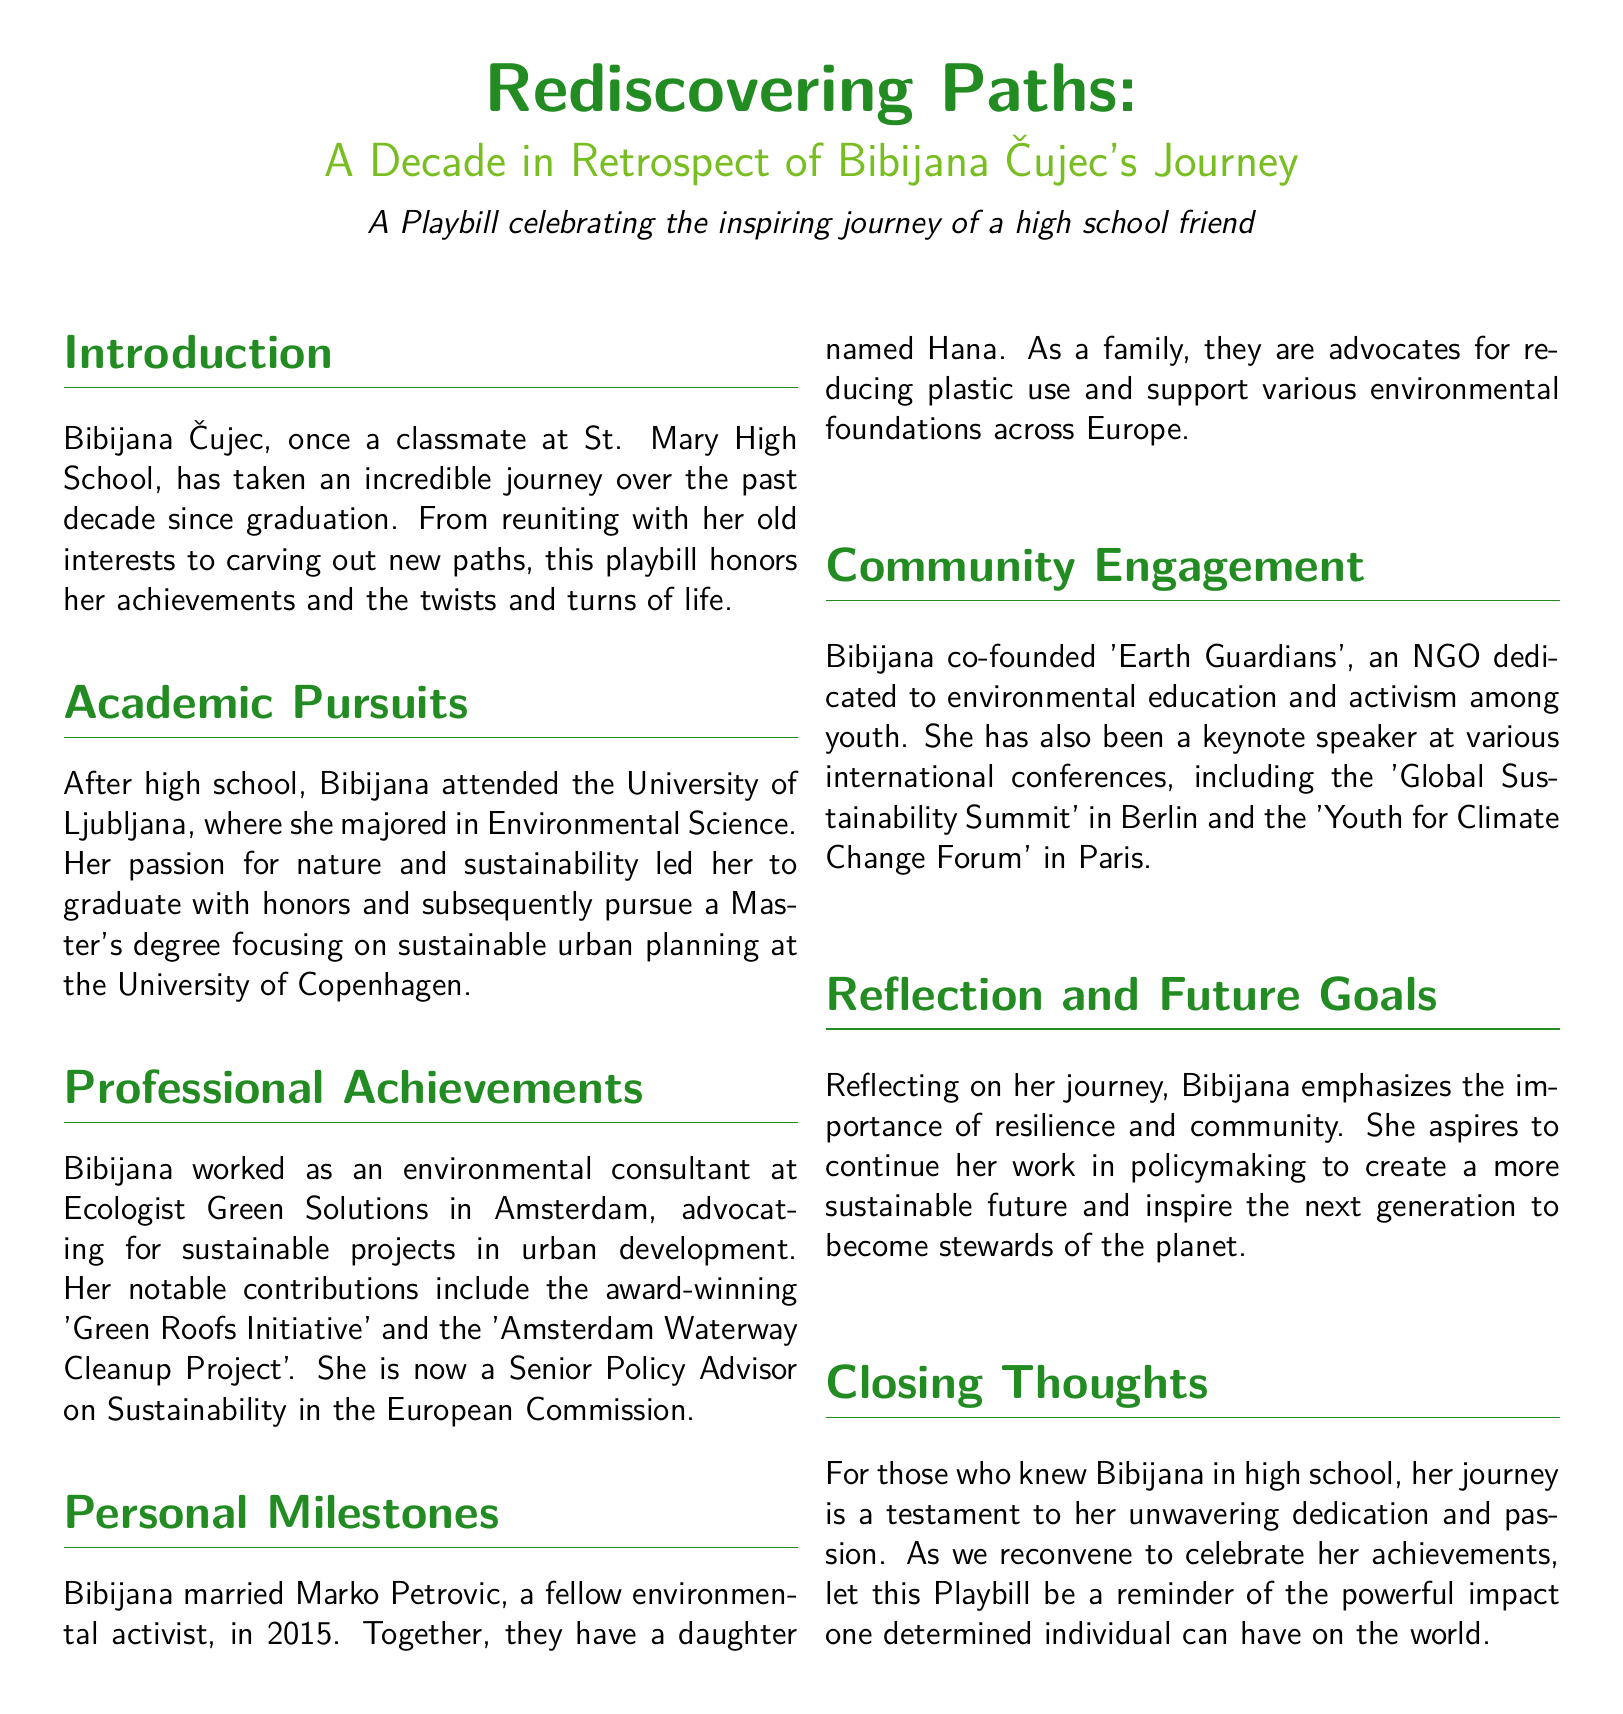What degree did Bibijana major in? The document states that Bibijana majored in Environmental Science at the University of Ljubljana.
Answer: Environmental Science What is the name of Bibijana's daughter? The document mentions that Bibijana has a daughter named Hana.
Answer: Hana In which year did Bibijana marry Marko Petrovic? According to the document, Bibijana married Marko Petrovic in 2015.
Answer: 2015 What is the name of the NGO co-founded by Bibijana? The document states that Bibijana co-founded 'Earth Guardians'.
Answer: Earth Guardians What is Bibijana's current position? The document indicates that she is now a Senior Policy Advisor on Sustainability in the European Commission.
Answer: Senior Policy Advisor on Sustainability Which university did Bibijana attend for her Master's degree? The document notes that she pursued her Master's degree at the University of Copenhagen.
Answer: University of Copenhagen What initiative was Bibijana notably involved with? The document highlights her involvement in the award-winning 'Green Roofs Initiative'.
Answer: Green Roofs Initiative What does Bibijana advocate for as a family? The document states that she and her family advocate for reducing plastic use.
Answer: Reducing plastic use What does she aspire to continue working on? The document mentions that she aspires to continue her work in policymaking.
Answer: Policymaking 